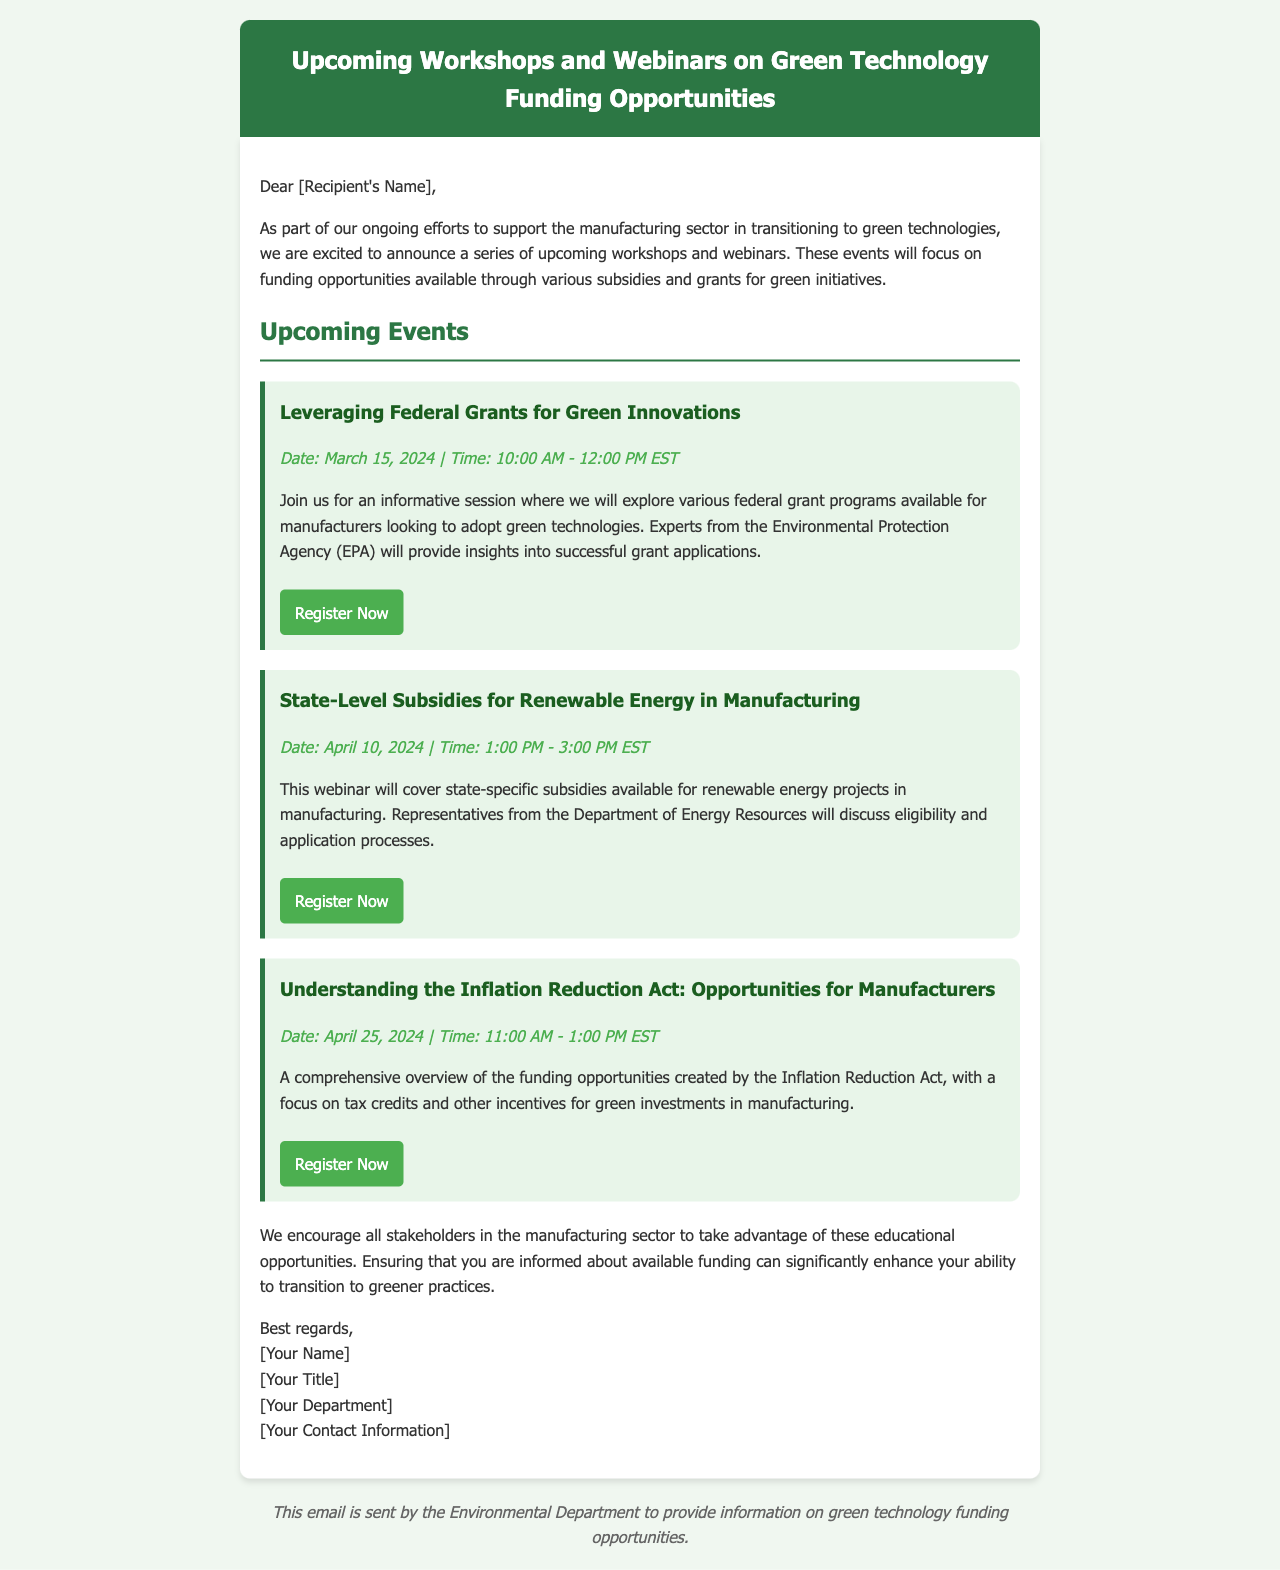What is the date for the first event? The first event is scheduled for March 15, 2024.
Answer: March 15, 2024 What is the main focus of the second webinar? The second webinar will cover state-specific subsidies for renewable energy projects in manufacturing.
Answer: State-specific subsidies for renewable energy Who will provide insights during the first event? Experts from the Environmental Protection Agency (EPA) will provide insights during the first event.
Answer: EPA What is the duration of the third webinar? The third webinar is scheduled to last for two hours.
Answer: 2 hours When will the webinar on the Inflation Reduction Act take place? The webinar on the Inflation Reduction Act is scheduled for April 25, 2024.
Answer: April 25, 2024 What type of funding opportunities will be discussed in the first workshop? Federal grant programs will be discussed in the first workshop.
Answer: Federal grant programs Which organization will discuss eligibility and application processes for the second event? Representatives from the Department of Energy Resources will discuss these processes.
Answer: Department of Energy Resources What is the registration button color for the events? The registration button is green.
Answer: Green 